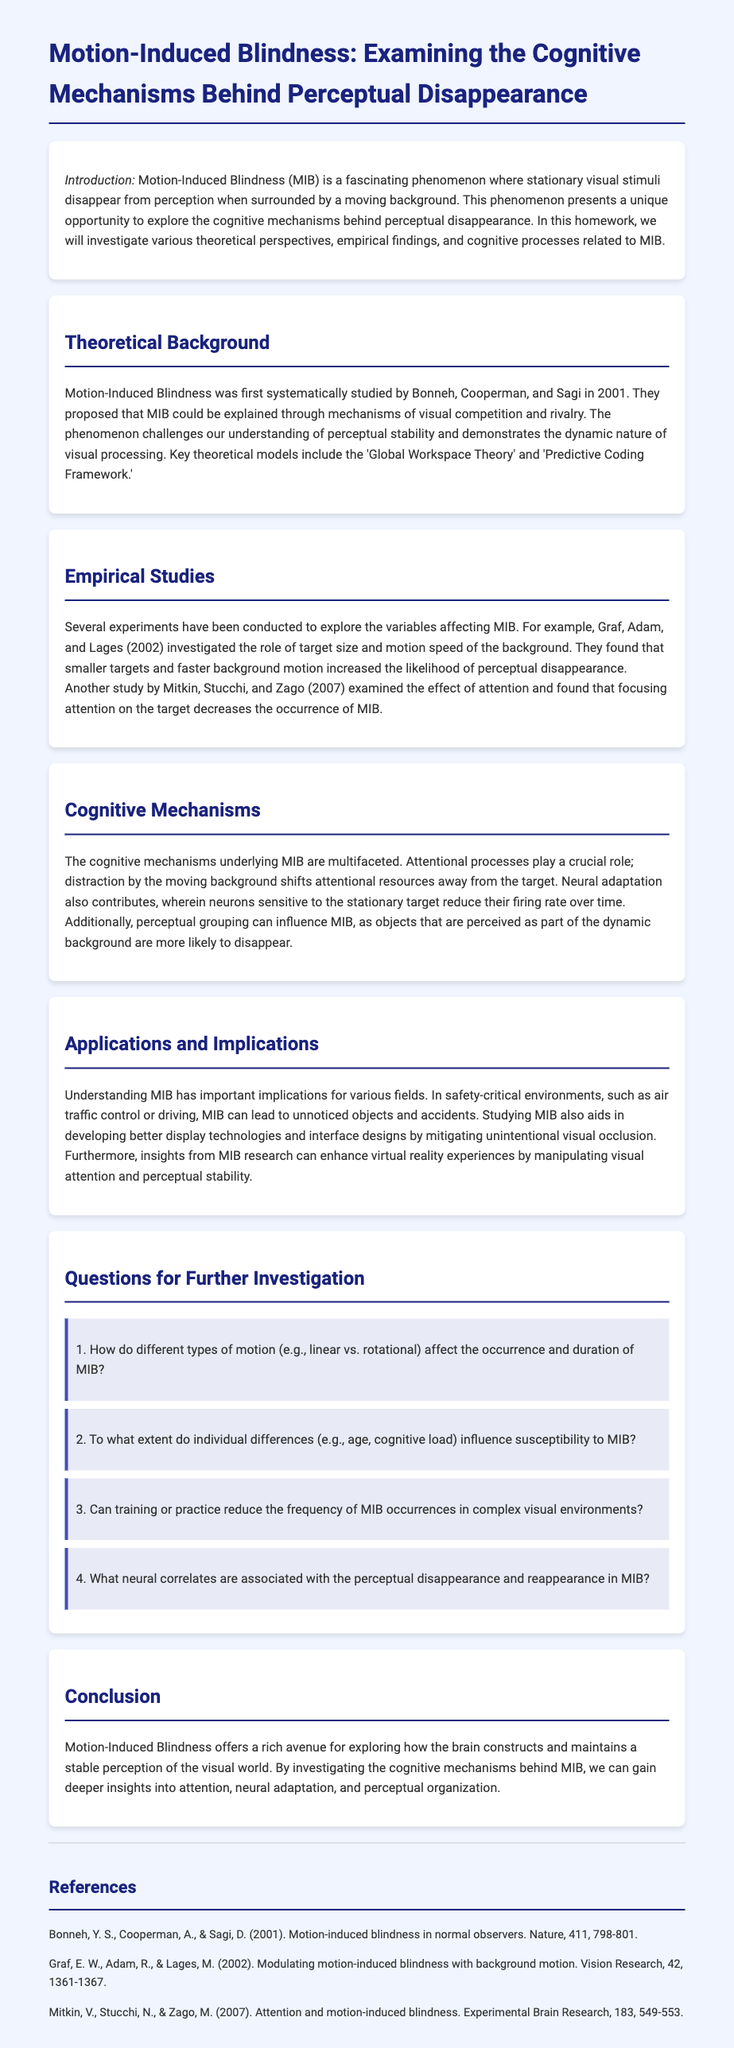What is the title of the homework document? The title is clearly stated in the heading of the document.
Answer: Motion-Induced Blindness: Examining the Cognitive Mechanisms Behind Perceptual Disappearance Who conducted the first systematic study of MIB? The document mentions the researchers and their contribution in the introduction section.
Answer: Bonneh, Cooperman, and Sagi What year was Motion-Induced Blindness first studied? The specific year of the first systematic study is provided in the theoretical background section.
Answer: 2001 What effect does attention have on MIB according to Mitkin et al. (2007)? The document summarizes empirical findings about attention's role in MIB.
Answer: Decreases the occurrence of MIB What are the key theoretical models mentioned in the document? Theoretical models related to MIB are listed in the theoretical background section.
Answer: Global Workspace Theory and Predictive Coding Framework What is one application of understanding MIB mentioned in the document? The paragraph on applications and implications highlights a specific area where MIB understanding is significant.
Answer: Safety-critical environments Can training or practice reduce the frequency of MIB occurrences? The questions listed for further investigation hint at exploring the impact of training.
Answer: Yes What did Graf, Adam, and Lages (2002) investigate in their study? The focus of the empirical study mentioned is explained in the document’s empirical studies section.
Answer: Role of target size and motion speed of the background 